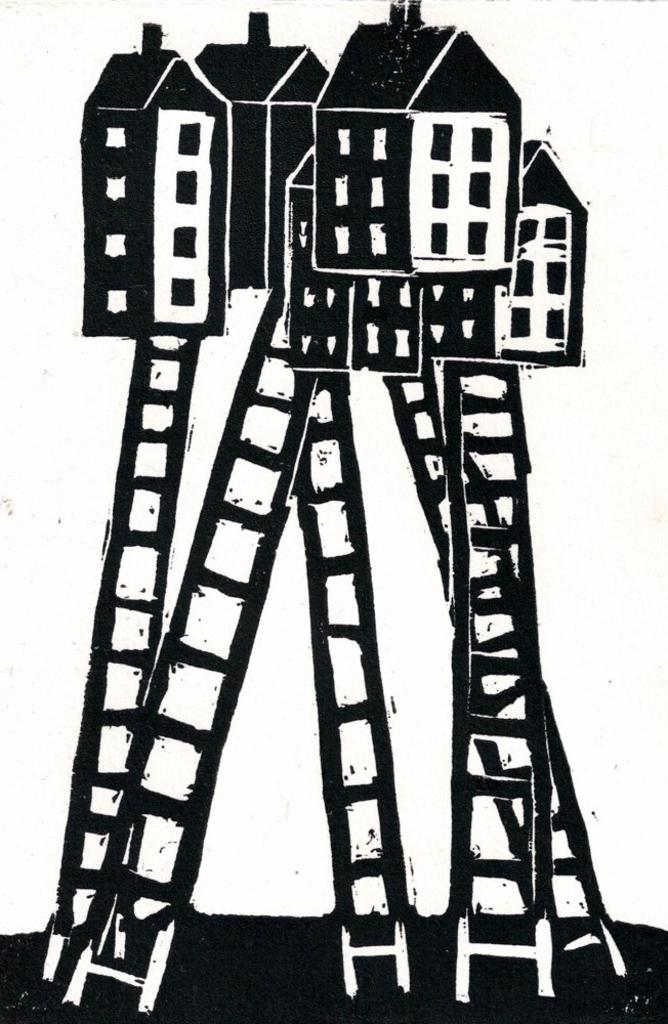What type of drawings can be seen in the image? There are drawings of houses, ladders, and windows in the image. Can you describe the drawings of houses in more detail? The drawings of houses include details such as windows. What other objects are depicted in the drawings? The drawings also include ladders. What type of straw is being used to drive the bean in the image? There is no straw or bean present in the image; it only contains drawings of houses, ladders, and windows. 